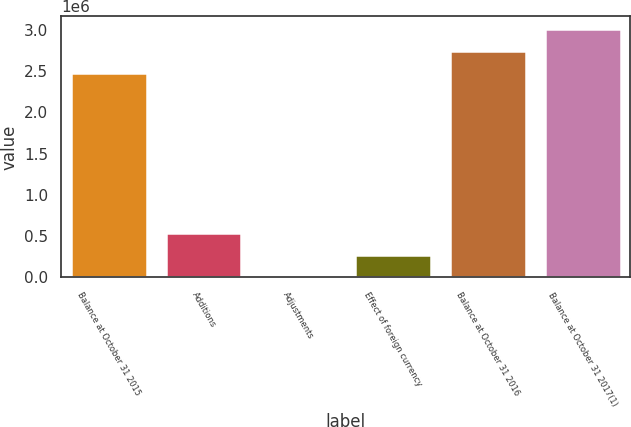Convert chart to OTSL. <chart><loc_0><loc_0><loc_500><loc_500><bar_chart><fcel>Balance at October 31 2015<fcel>Additions<fcel>Adjustments<fcel>Effect of foreign currency<fcel>Balance at October 31 2016<fcel>Balance at October 31 2017(1)<nl><fcel>2.47124e+06<fcel>541743<fcel>435<fcel>271089<fcel>2.74189e+06<fcel>3.01255e+06<nl></chart> 